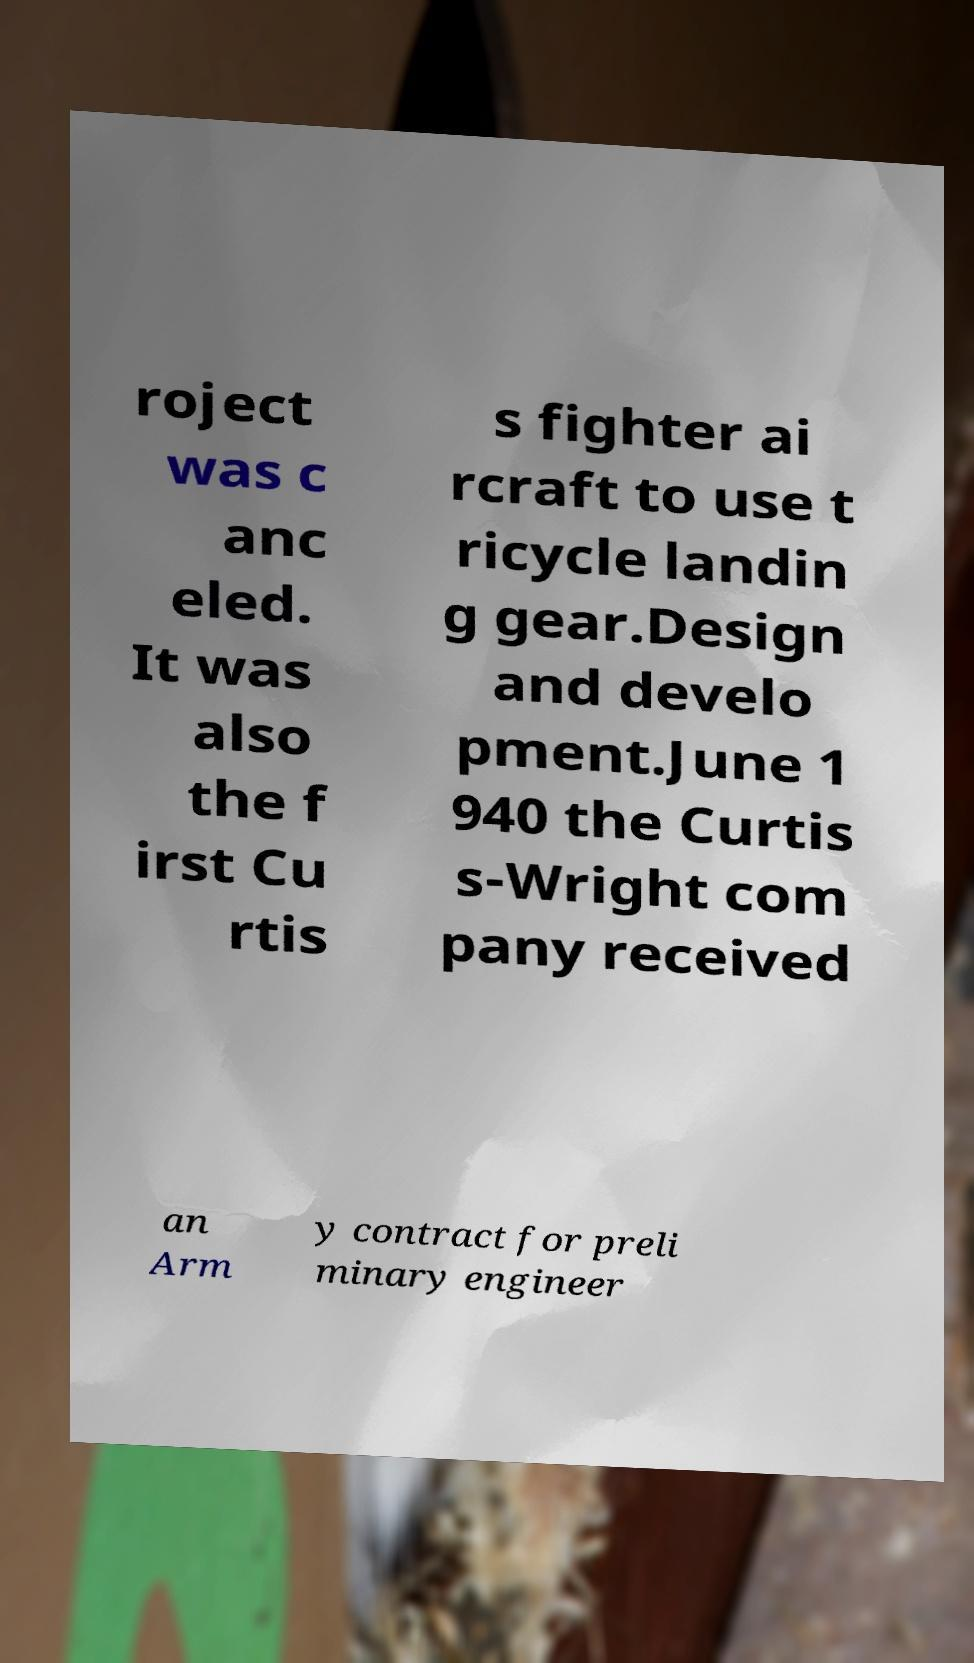Can you read and provide the text displayed in the image?This photo seems to have some interesting text. Can you extract and type it out for me? roject was c anc eled. It was also the f irst Cu rtis s fighter ai rcraft to use t ricycle landin g gear.Design and develo pment.June 1 940 the Curtis s-Wright com pany received an Arm y contract for preli minary engineer 